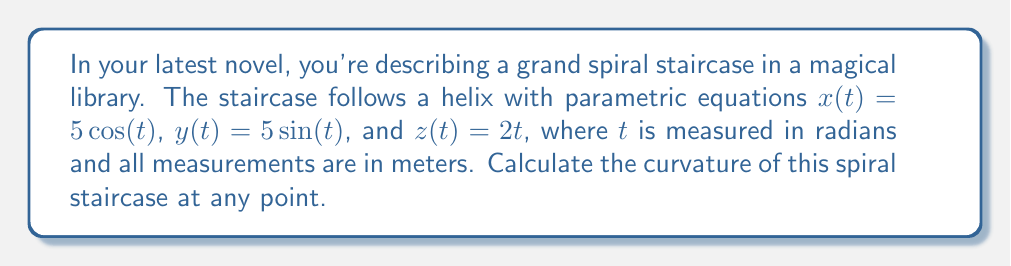Help me with this question. To calculate the curvature of the spiral staircase, we'll follow these steps:

1) First, we need to find the first and second derivatives of the position vector $\mathbf{r}(t) = \langle 5\cos(t), 5\sin(t), 2t \rangle$.

   $\mathbf{r}'(t) = \langle -5\sin(t), 5\cos(t), 2 \rangle$
   $\mathbf{r}''(t) = \langle -5\cos(t), -5\sin(t), 0 \rangle$

2) The curvature formula for a vector-valued function is:

   $$\kappa = \frac{|\mathbf{r}'(t) \times \mathbf{r}''(t)|}{|\mathbf{r}'(t)|^3}$$

3) Let's calculate the cross product $\mathbf{r}'(t) \times \mathbf{r}''(t)$:

   $$\begin{vmatrix} 
   \mathbf{i} & \mathbf{j} & \mathbf{k} \\
   -5\sin(t) & 5\cos(t) & 2 \\
   -5\cos(t) & -5\sin(t) & 0
   \end{vmatrix}$$

   $= \langle -10\sin(t), -10\cos(t), -25\sin^2(t) - 25\cos^2(t) \rangle$
   $= \langle -10\sin(t), -10\cos(t), -25 \rangle$

4) The magnitude of this cross product is:

   $|\mathbf{r}'(t) \times \mathbf{r}''(t)| = \sqrt{100\sin^2(t) + 100\cos^2(t) + 625} = \sqrt{725} = 5\sqrt{29}$

5) Now, let's calculate $|\mathbf{r}'(t)|$:

   $|\mathbf{r}'(t)| = \sqrt{25\sin^2(t) + 25\cos^2(t) + 4} = \sqrt{29}$

6) Therefore, $|\mathbf{r}'(t)|^3 = (\sqrt{29})^3 = 29\sqrt{29}$

7) Substituting these values into the curvature formula:

   $$\kappa = \frac{5\sqrt{29}}{29\sqrt{29}} = \frac{5}{29}$$

This curvature is constant, meaning the spiral staircase has the same "tightness" of curve at every point.
Answer: The curvature of the spiral staircase is $\frac{5}{29}$ at any point. 